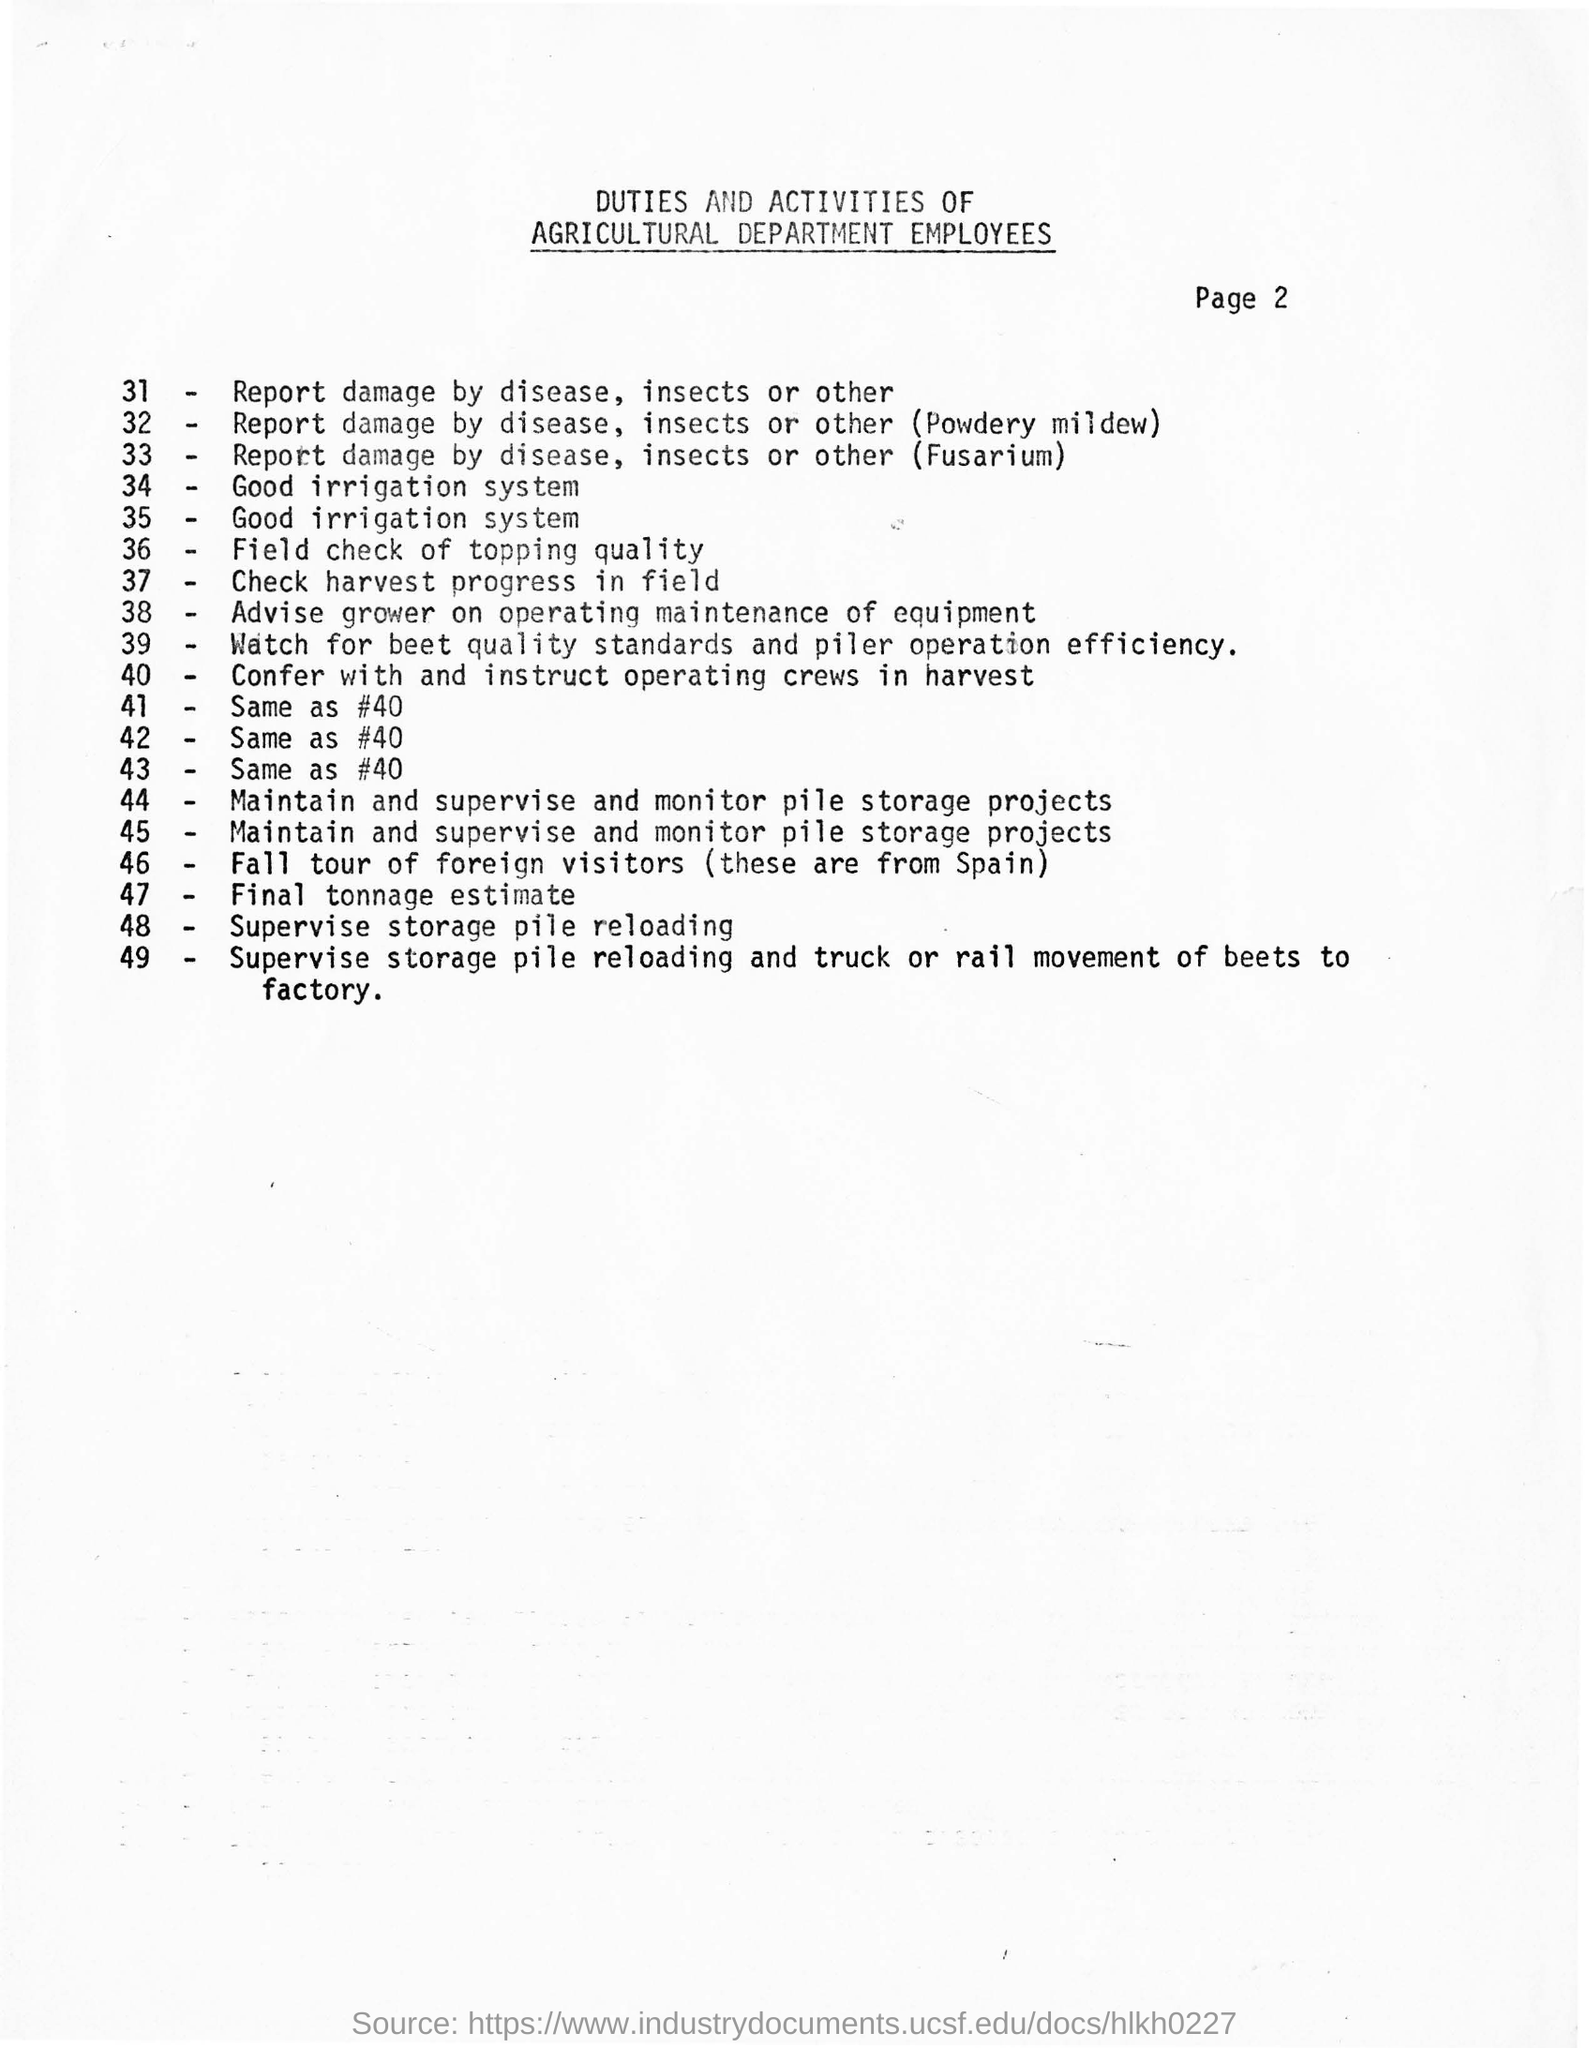Duties and activities of which department employees are mentioned?
Give a very brief answer. AGRICULTURAL. Foreign visitors are from which country?
Your response must be concise. SPAIN. Which page number is mentioned?
Your answer should be very brief. 2. 